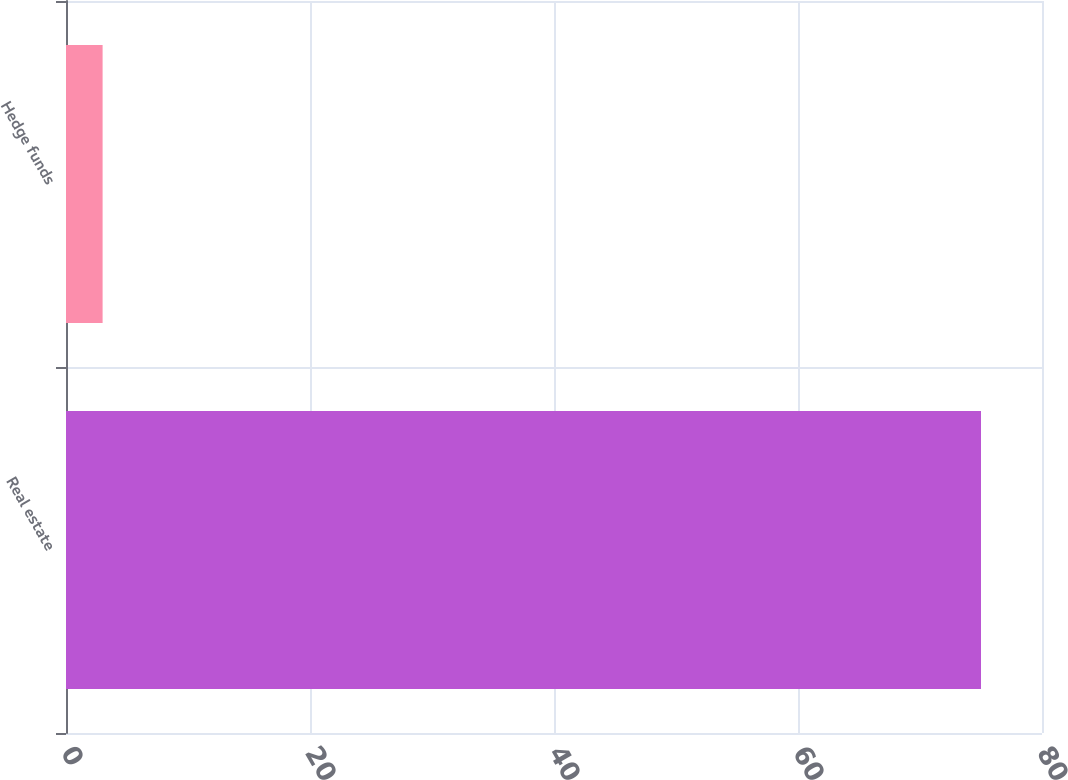Convert chart to OTSL. <chart><loc_0><loc_0><loc_500><loc_500><bar_chart><fcel>Real estate<fcel>Hedge funds<nl><fcel>75<fcel>3<nl></chart> 